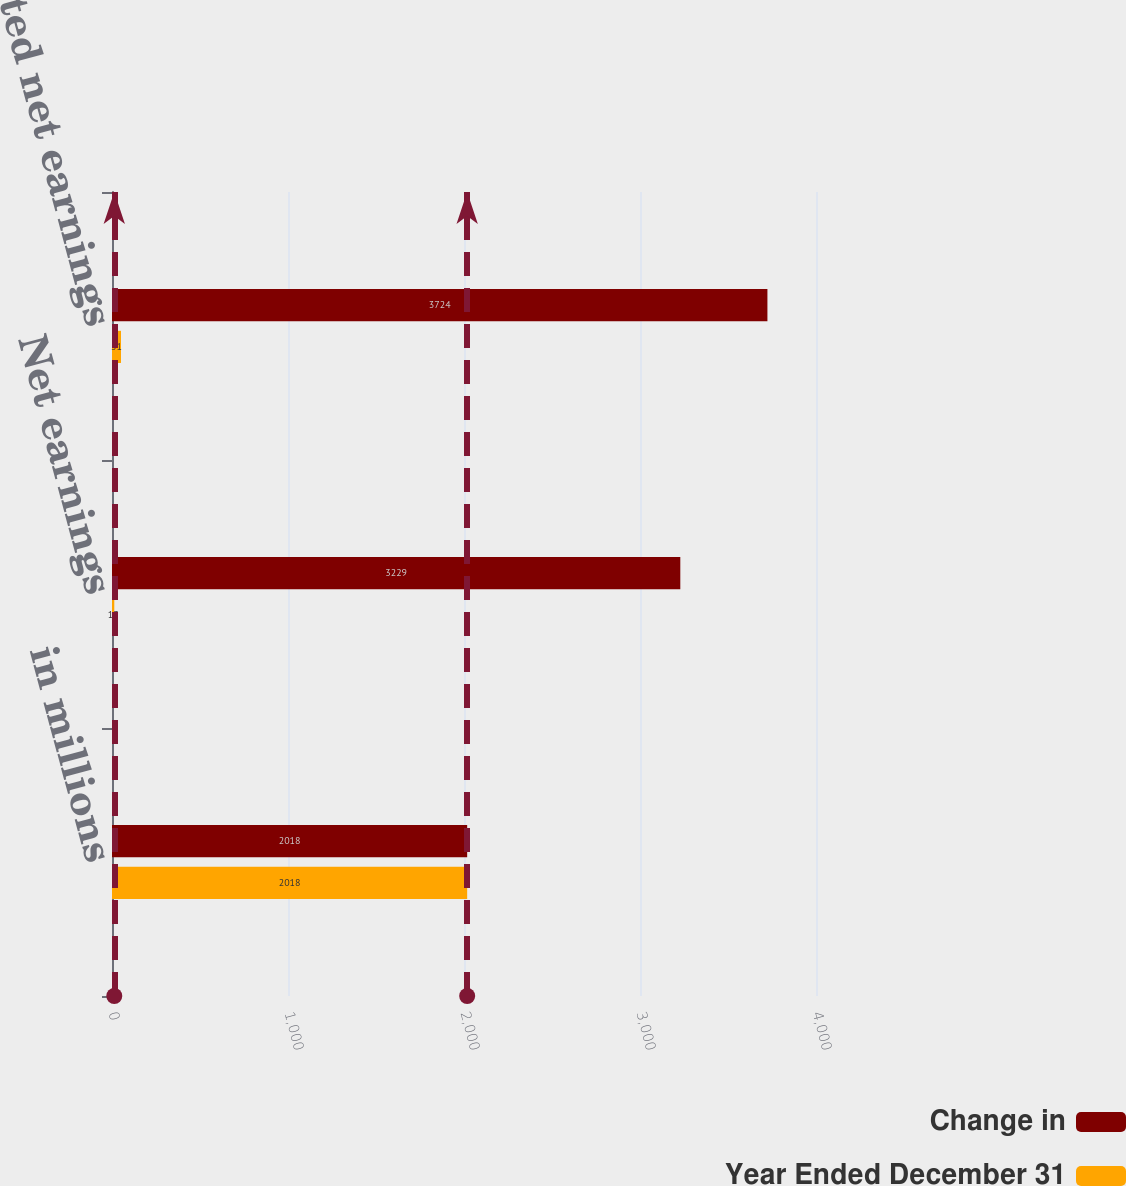Convert chart. <chart><loc_0><loc_0><loc_500><loc_500><stacked_bar_chart><ecel><fcel>in millions<fcel>Net earnings<fcel>MTM-adjusted net earnings<nl><fcel>Change in<fcel>2018<fcel>3229<fcel>3724<nl><fcel>Year Ended December 31<fcel>2018<fcel>13<fcel>51<nl></chart> 